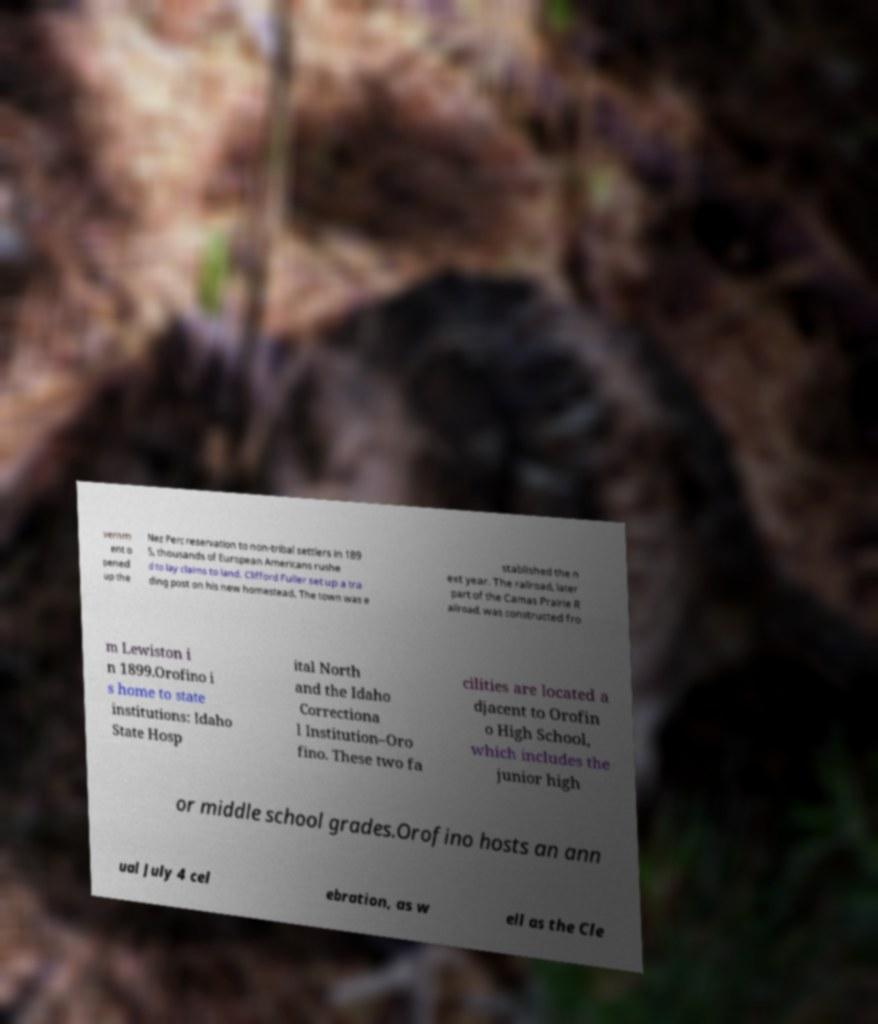Can you read and provide the text displayed in the image?This photo seems to have some interesting text. Can you extract and type it out for me? vernm ent o pened up the Nez Perc reservation to non-tribal settlers in 189 5, thousands of European Americans rushe d to lay claims to land. Clifford Fuller set up a tra ding post on his new homestead. The town was e stablished the n ext year. The railroad, later part of the Camas Prairie R ailroad, was constructed fro m Lewiston i n 1899.Orofino i s home to state institutions: Idaho State Hosp ital North and the Idaho Correctiona l Institution–Oro fino. These two fa cilities are located a djacent to Orofin o High School, which includes the junior high or middle school grades.Orofino hosts an ann ual July 4 cel ebration, as w ell as the Cle 